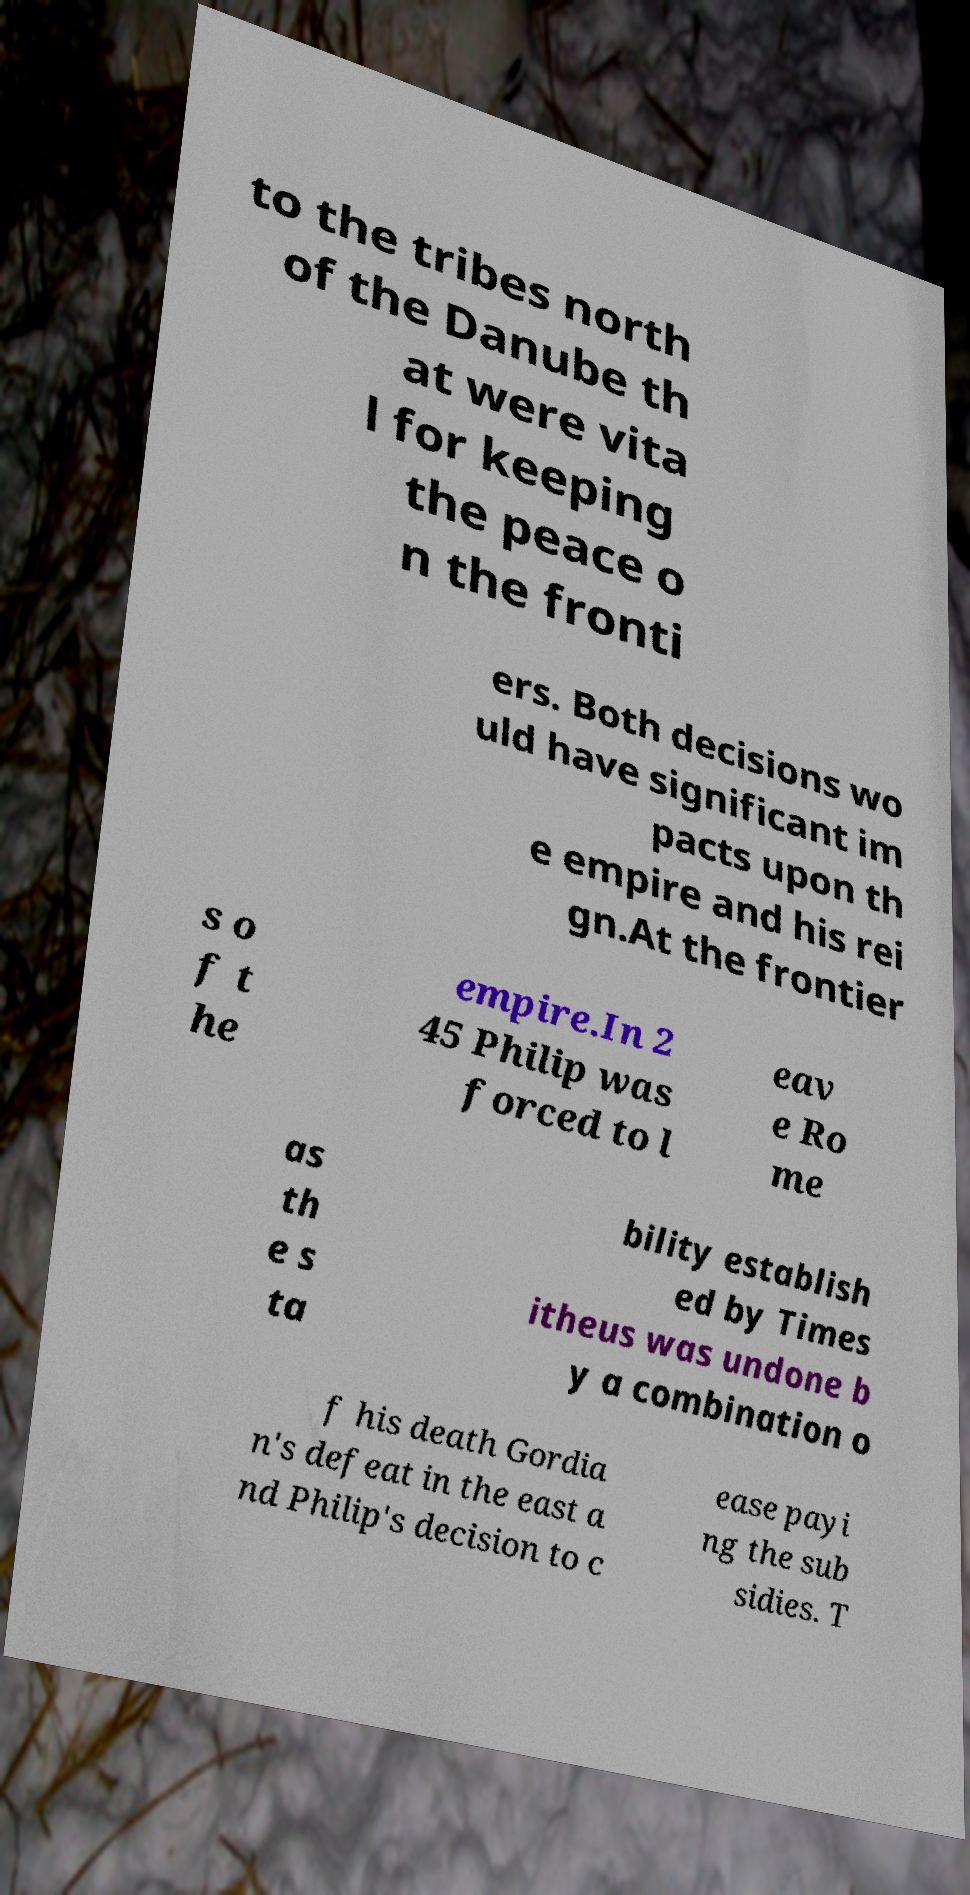For documentation purposes, I need the text within this image transcribed. Could you provide that? to the tribes north of the Danube th at were vita l for keeping the peace o n the fronti ers. Both decisions wo uld have significant im pacts upon th e empire and his rei gn.At the frontier s o f t he empire.In 2 45 Philip was forced to l eav e Ro me as th e s ta bility establish ed by Times itheus was undone b y a combination o f his death Gordia n's defeat in the east a nd Philip's decision to c ease payi ng the sub sidies. T 